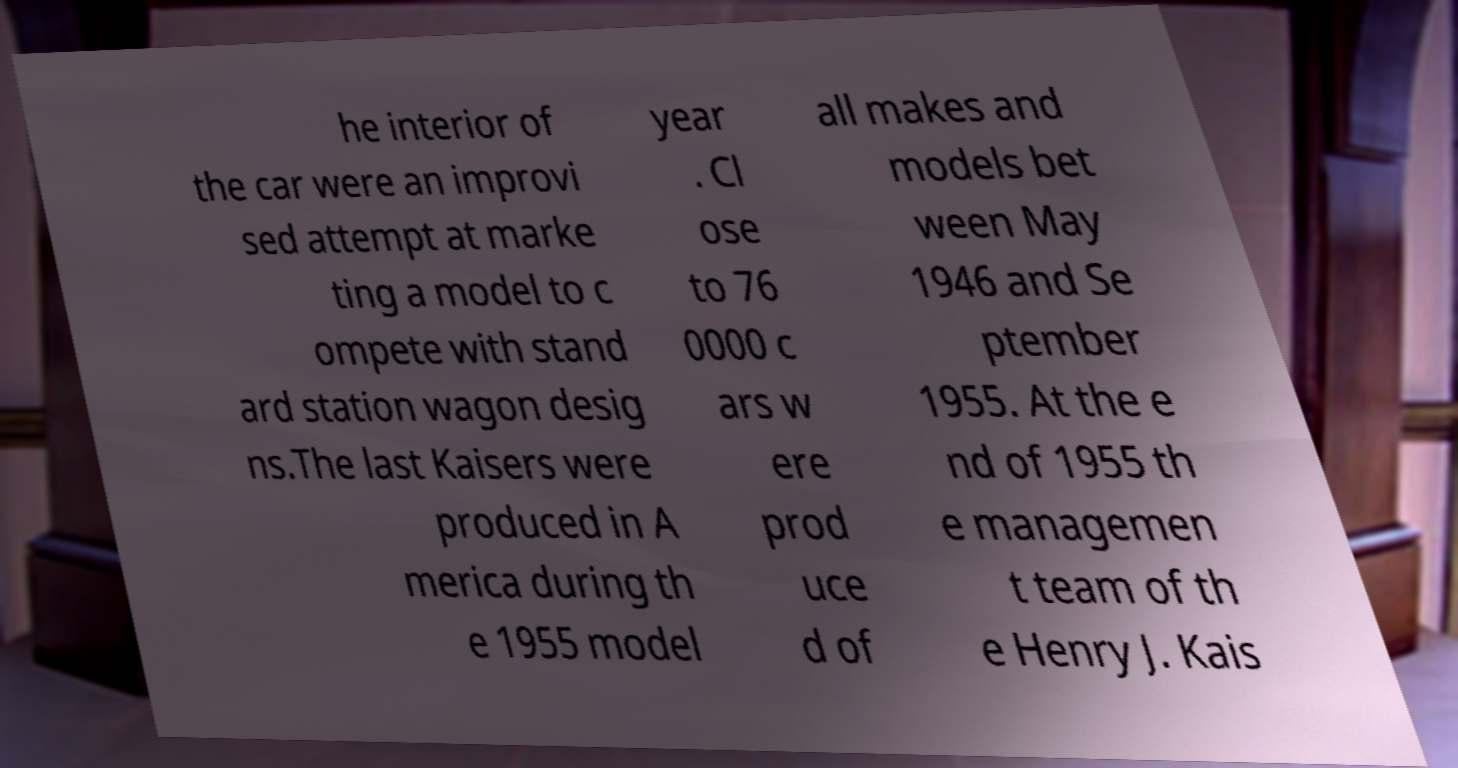Please identify and transcribe the text found in this image. he interior of the car were an improvi sed attempt at marke ting a model to c ompete with stand ard station wagon desig ns.The last Kaisers were produced in A merica during th e 1955 model year . Cl ose to 76 0000 c ars w ere prod uce d of all makes and models bet ween May 1946 and Se ptember 1955. At the e nd of 1955 th e managemen t team of th e Henry J. Kais 